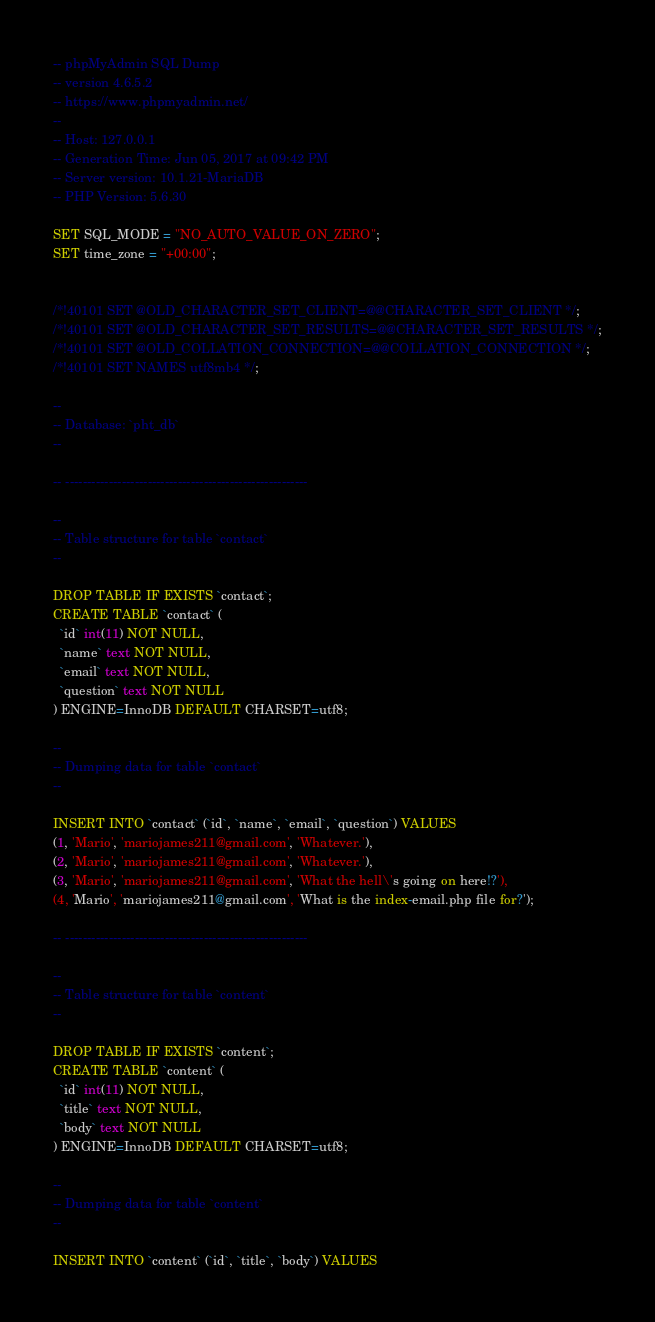<code> <loc_0><loc_0><loc_500><loc_500><_SQL_>-- phpMyAdmin SQL Dump
-- version 4.6.5.2
-- https://www.phpmyadmin.net/
--
-- Host: 127.0.0.1
-- Generation Time: Jun 05, 2017 at 09:42 PM
-- Server version: 10.1.21-MariaDB
-- PHP Version: 5.6.30

SET SQL_MODE = "NO_AUTO_VALUE_ON_ZERO";
SET time_zone = "+00:00";


/*!40101 SET @OLD_CHARACTER_SET_CLIENT=@@CHARACTER_SET_CLIENT */;
/*!40101 SET @OLD_CHARACTER_SET_RESULTS=@@CHARACTER_SET_RESULTS */;
/*!40101 SET @OLD_COLLATION_CONNECTION=@@COLLATION_CONNECTION */;
/*!40101 SET NAMES utf8mb4 */;

--
-- Database: `pht_db`
--

-- --------------------------------------------------------

--
-- Table structure for table `contact`
--

DROP TABLE IF EXISTS `contact`;
CREATE TABLE `contact` (
  `id` int(11) NOT NULL,
  `name` text NOT NULL,
  `email` text NOT NULL,
  `question` text NOT NULL
) ENGINE=InnoDB DEFAULT CHARSET=utf8;

--
-- Dumping data for table `contact`
--

INSERT INTO `contact` (`id`, `name`, `email`, `question`) VALUES
(1, 'Mario', 'mariojames211@gmail.com', 'Whatever.'),
(2, 'Mario', 'mariojames211@gmail.com', 'Whatever.'),
(3, 'Mario', 'mariojames211@gmail.com', 'What the hell\'s going on here!?'),
(4, 'Mario', 'mariojames211@gmail.com', 'What is the index-email.php file for?');

-- --------------------------------------------------------

--
-- Table structure for table `content`
--

DROP TABLE IF EXISTS `content`;
CREATE TABLE `content` (
  `id` int(11) NOT NULL,
  `title` text NOT NULL,
  `body` text NOT NULL
) ENGINE=InnoDB DEFAULT CHARSET=utf8;

--
-- Dumping data for table `content`
--

INSERT INTO `content` (`id`, `title`, `body`) VALUES</code> 